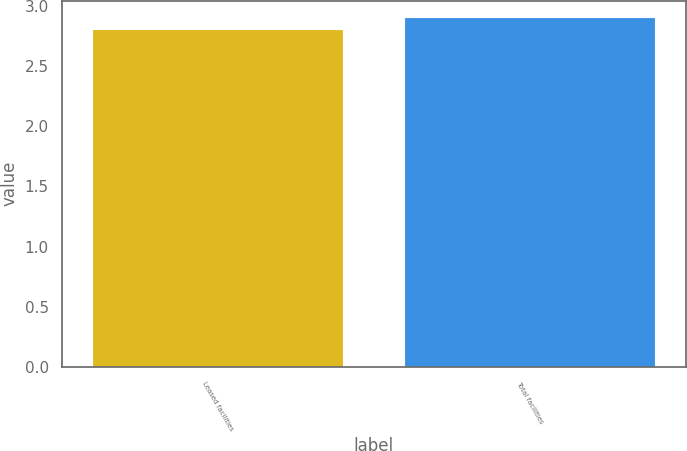<chart> <loc_0><loc_0><loc_500><loc_500><bar_chart><fcel>Leased facilities<fcel>Total facilities<nl><fcel>2.8<fcel>2.9<nl></chart> 